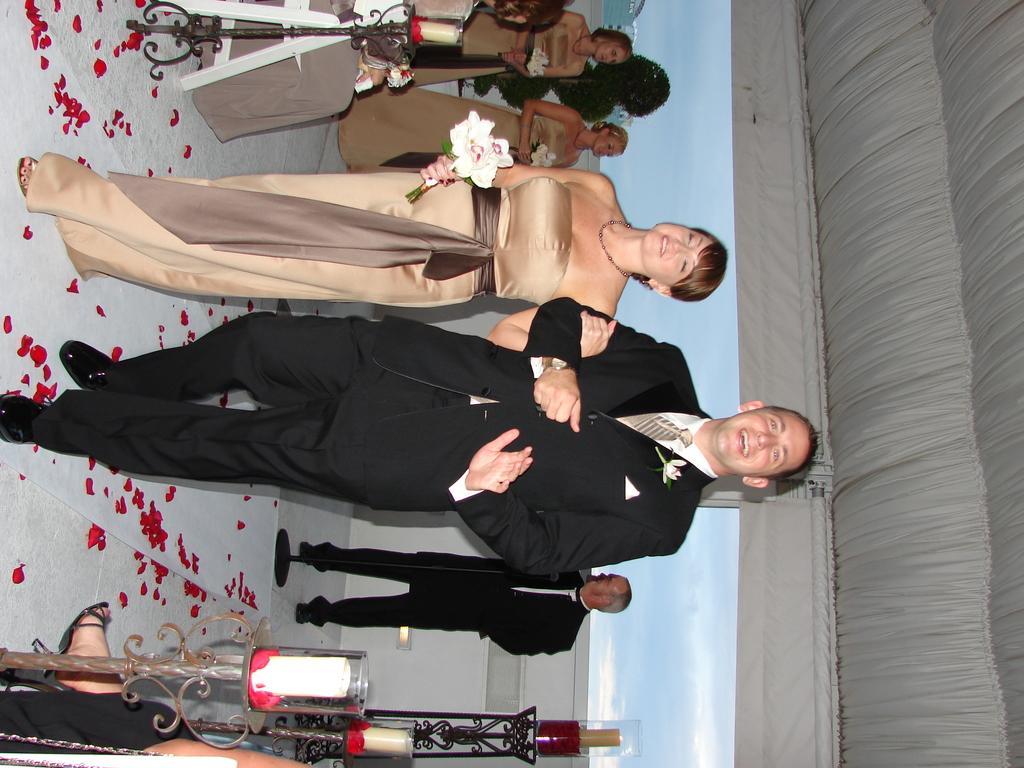How would you summarize this image in a sentence or two? In this image, we can see a group of people. Here a woman and men are smiling and walking. Here we can see a woman is holding a hand of a man and a flower bouquet. At the top and bottom of the image, we can see candles, glass objects and stands. Background we can see the sky. On the right side of the image, we can see pole and cloth. 